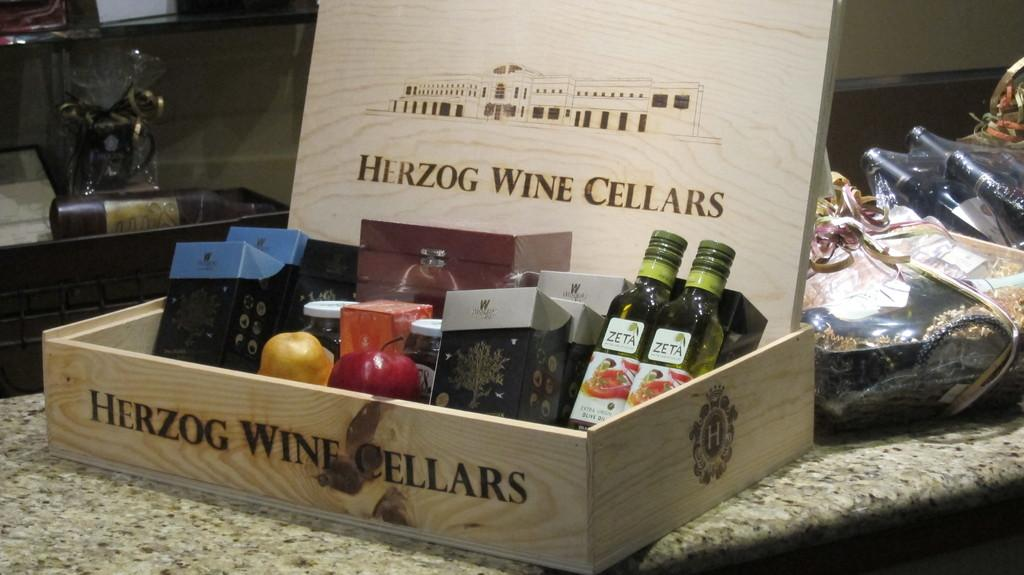<image>
Render a clear and concise summary of the photo. A wooden box with bottles and fruit in it says Herzog Wine Cellers. 